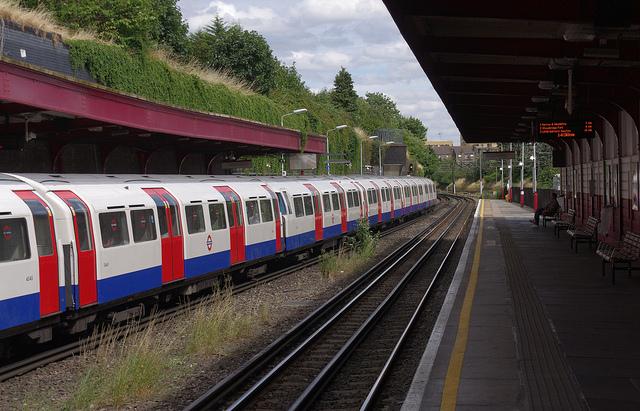Are there trees visible?
Answer briefly. Yes. Could this train be themed for 4th of July?
Keep it brief. Yes. How many people are around?
Quick response, please. 0. What colors make up the train?
Short answer required. Red, white and blue. 